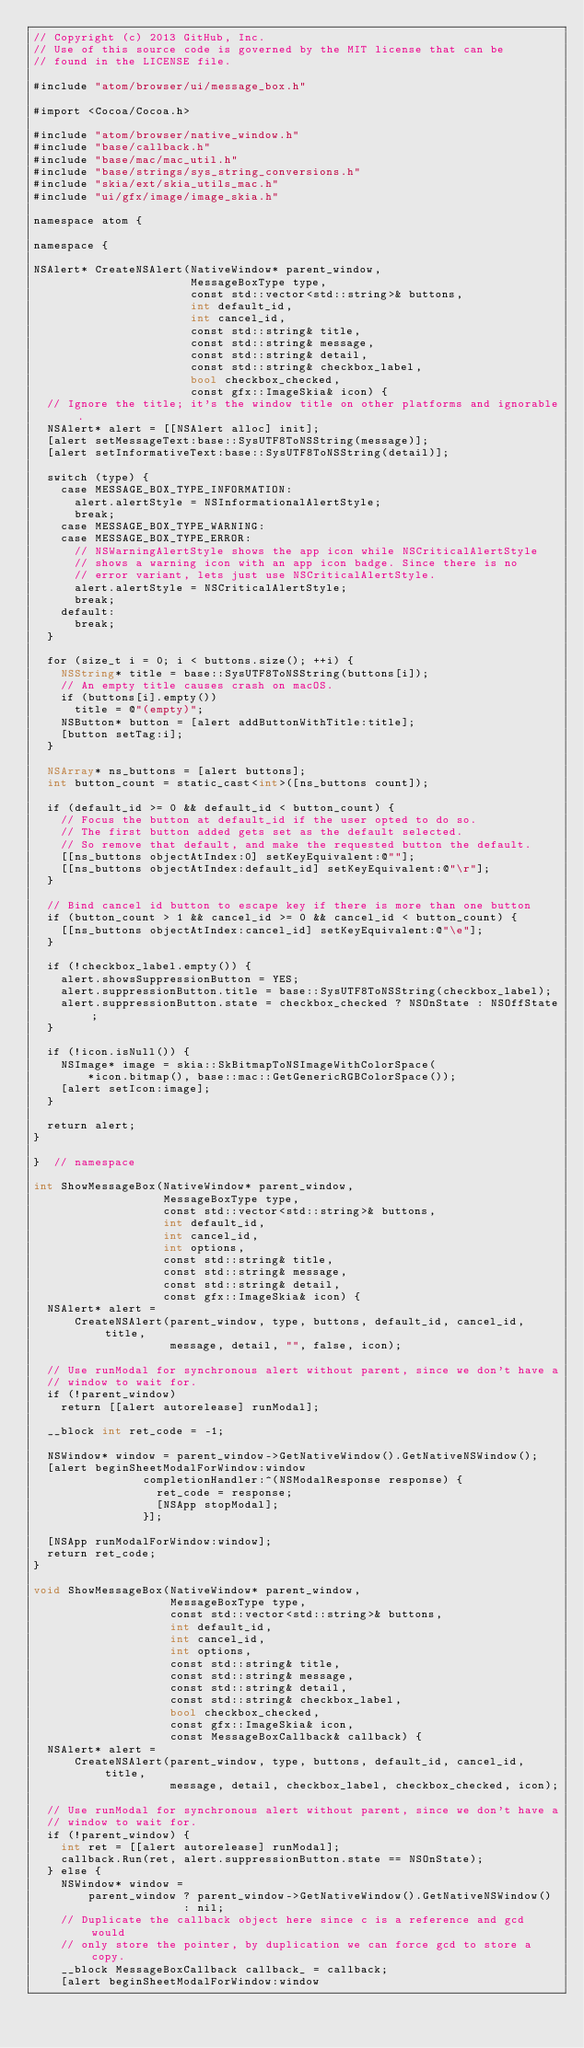Convert code to text. <code><loc_0><loc_0><loc_500><loc_500><_ObjectiveC_>// Copyright (c) 2013 GitHub, Inc.
// Use of this source code is governed by the MIT license that can be
// found in the LICENSE file.

#include "atom/browser/ui/message_box.h"

#import <Cocoa/Cocoa.h>

#include "atom/browser/native_window.h"
#include "base/callback.h"
#include "base/mac/mac_util.h"
#include "base/strings/sys_string_conversions.h"
#include "skia/ext/skia_utils_mac.h"
#include "ui/gfx/image/image_skia.h"

namespace atom {

namespace {

NSAlert* CreateNSAlert(NativeWindow* parent_window,
                       MessageBoxType type,
                       const std::vector<std::string>& buttons,
                       int default_id,
                       int cancel_id,
                       const std::string& title,
                       const std::string& message,
                       const std::string& detail,
                       const std::string& checkbox_label,
                       bool checkbox_checked,
                       const gfx::ImageSkia& icon) {
  // Ignore the title; it's the window title on other platforms and ignorable.
  NSAlert* alert = [[NSAlert alloc] init];
  [alert setMessageText:base::SysUTF8ToNSString(message)];
  [alert setInformativeText:base::SysUTF8ToNSString(detail)];

  switch (type) {
    case MESSAGE_BOX_TYPE_INFORMATION:
      alert.alertStyle = NSInformationalAlertStyle;
      break;
    case MESSAGE_BOX_TYPE_WARNING:
    case MESSAGE_BOX_TYPE_ERROR:
      // NSWarningAlertStyle shows the app icon while NSCriticalAlertStyle
      // shows a warning icon with an app icon badge. Since there is no
      // error variant, lets just use NSCriticalAlertStyle.
      alert.alertStyle = NSCriticalAlertStyle;
      break;
    default:
      break;
  }

  for (size_t i = 0; i < buttons.size(); ++i) {
    NSString* title = base::SysUTF8ToNSString(buttons[i]);
    // An empty title causes crash on macOS.
    if (buttons[i].empty())
      title = @"(empty)";
    NSButton* button = [alert addButtonWithTitle:title];
    [button setTag:i];
  }

  NSArray* ns_buttons = [alert buttons];
  int button_count = static_cast<int>([ns_buttons count]);

  if (default_id >= 0 && default_id < button_count) {
    // Focus the button at default_id if the user opted to do so.
    // The first button added gets set as the default selected.
    // So remove that default, and make the requested button the default.
    [[ns_buttons objectAtIndex:0] setKeyEquivalent:@""];
    [[ns_buttons objectAtIndex:default_id] setKeyEquivalent:@"\r"];
  }

  // Bind cancel id button to escape key if there is more than one button
  if (button_count > 1 && cancel_id >= 0 && cancel_id < button_count) {
    [[ns_buttons objectAtIndex:cancel_id] setKeyEquivalent:@"\e"];
  }

  if (!checkbox_label.empty()) {
    alert.showsSuppressionButton = YES;
    alert.suppressionButton.title = base::SysUTF8ToNSString(checkbox_label);
    alert.suppressionButton.state = checkbox_checked ? NSOnState : NSOffState;
  }

  if (!icon.isNull()) {
    NSImage* image = skia::SkBitmapToNSImageWithColorSpace(
        *icon.bitmap(), base::mac::GetGenericRGBColorSpace());
    [alert setIcon:image];
  }

  return alert;
}

}  // namespace

int ShowMessageBox(NativeWindow* parent_window,
                   MessageBoxType type,
                   const std::vector<std::string>& buttons,
                   int default_id,
                   int cancel_id,
                   int options,
                   const std::string& title,
                   const std::string& message,
                   const std::string& detail,
                   const gfx::ImageSkia& icon) {
  NSAlert* alert =
      CreateNSAlert(parent_window, type, buttons, default_id, cancel_id, title,
                    message, detail, "", false, icon);

  // Use runModal for synchronous alert without parent, since we don't have a
  // window to wait for.
  if (!parent_window)
    return [[alert autorelease] runModal];

  __block int ret_code = -1;

  NSWindow* window = parent_window->GetNativeWindow().GetNativeNSWindow();
  [alert beginSheetModalForWindow:window
                completionHandler:^(NSModalResponse response) {
                  ret_code = response;
                  [NSApp stopModal];
                }];

  [NSApp runModalForWindow:window];
  return ret_code;
}

void ShowMessageBox(NativeWindow* parent_window,
                    MessageBoxType type,
                    const std::vector<std::string>& buttons,
                    int default_id,
                    int cancel_id,
                    int options,
                    const std::string& title,
                    const std::string& message,
                    const std::string& detail,
                    const std::string& checkbox_label,
                    bool checkbox_checked,
                    const gfx::ImageSkia& icon,
                    const MessageBoxCallback& callback) {
  NSAlert* alert =
      CreateNSAlert(parent_window, type, buttons, default_id, cancel_id, title,
                    message, detail, checkbox_label, checkbox_checked, icon);

  // Use runModal for synchronous alert without parent, since we don't have a
  // window to wait for.
  if (!parent_window) {
    int ret = [[alert autorelease] runModal];
    callback.Run(ret, alert.suppressionButton.state == NSOnState);
  } else {
    NSWindow* window =
        parent_window ? parent_window->GetNativeWindow().GetNativeNSWindow()
                      : nil;
    // Duplicate the callback object here since c is a reference and gcd would
    // only store the pointer, by duplication we can force gcd to store a copy.
    __block MessageBoxCallback callback_ = callback;
    [alert beginSheetModalForWindow:window</code> 